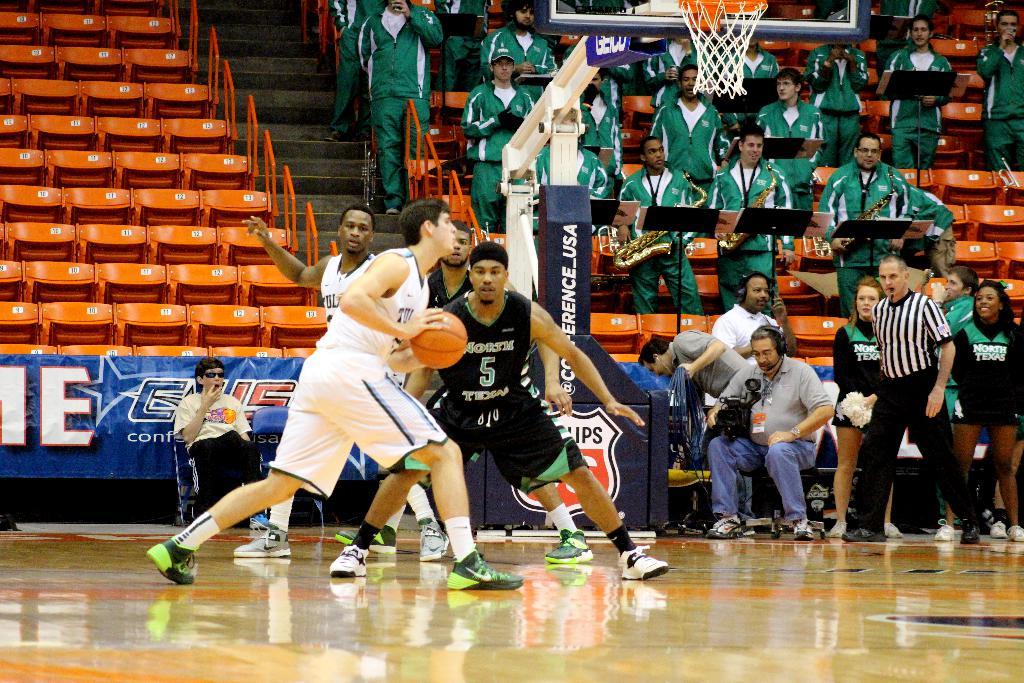What is the number of the defending player?
Give a very brief answer. 5. What is the team in black?
Provide a succinct answer. Unanswerable. 